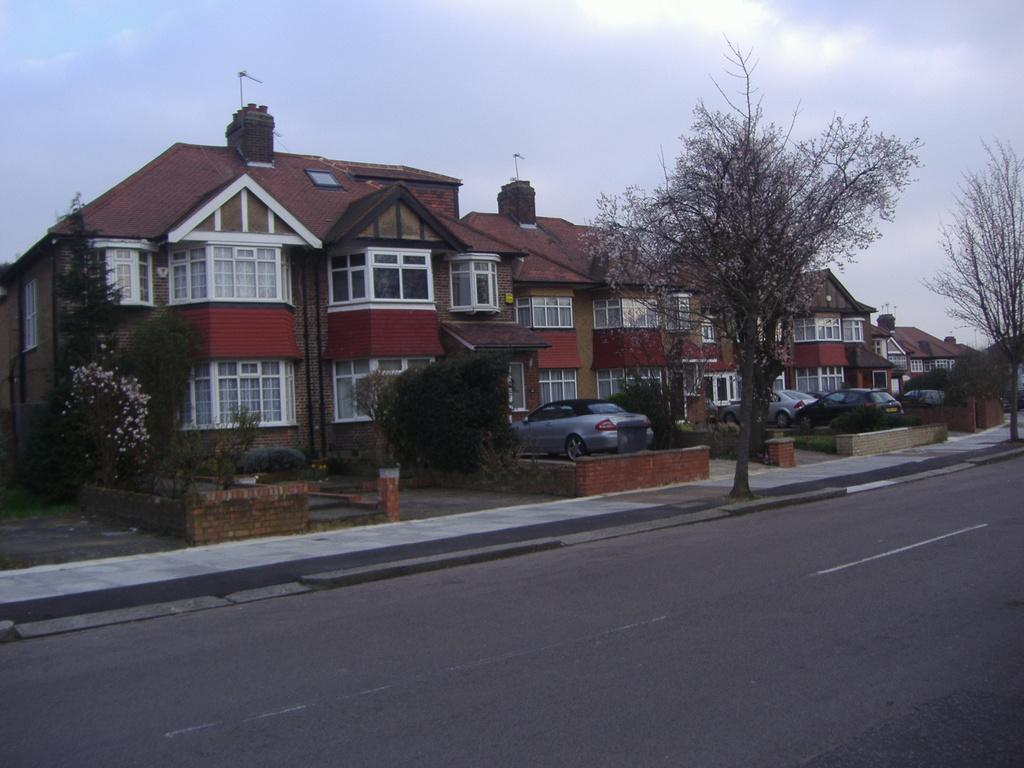What is the main feature of the image? There is a road in the image. What can be seen on the right side of the image? There are trees on the right side of the image. What is located in the middle of the image? There are many houses in the middle of the image. What is visible in the background of the image? The background of the image is the sky. How many chairs are placed around the cake in the image? There is no cake or chairs present in the image. 